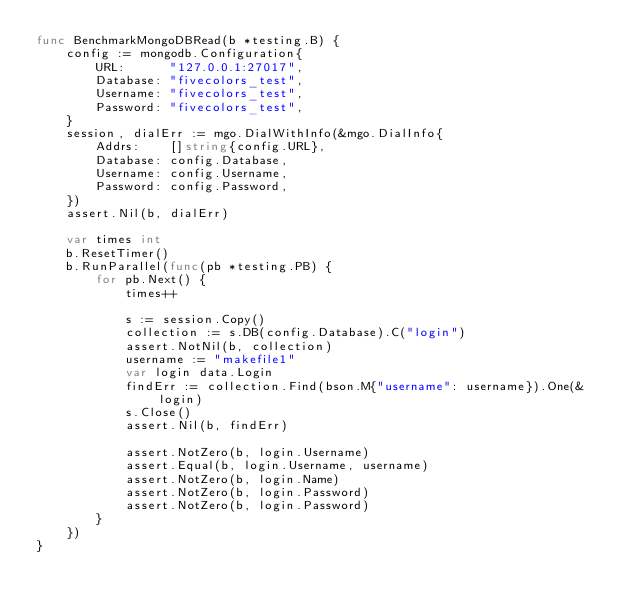Convert code to text. <code><loc_0><loc_0><loc_500><loc_500><_Go_>func BenchmarkMongoDBRead(b *testing.B) {
	config := mongodb.Configuration{
		URL:      "127.0.0.1:27017",
		Database: "fivecolors_test",
		Username: "fivecolors_test",
		Password: "fivecolors_test",
	}
	session, dialErr := mgo.DialWithInfo(&mgo.DialInfo{
		Addrs:    []string{config.URL},
		Database: config.Database,
		Username: config.Username,
		Password: config.Password,
	})
	assert.Nil(b, dialErr)

	var times int
	b.ResetTimer()
	b.RunParallel(func(pb *testing.PB) {
		for pb.Next() {
			times++

			s := session.Copy()
			collection := s.DB(config.Database).C("login")
			assert.NotNil(b, collection)
			username := "makefile1"
			var login data.Login
			findErr := collection.Find(bson.M{"username": username}).One(&login)
			s.Close()
			assert.Nil(b, findErr)

			assert.NotZero(b, login.Username)
			assert.Equal(b, login.Username, username)
			assert.NotZero(b, login.Name)
			assert.NotZero(b, login.Password)
			assert.NotZero(b, login.Password)
		}
	})
}
</code> 